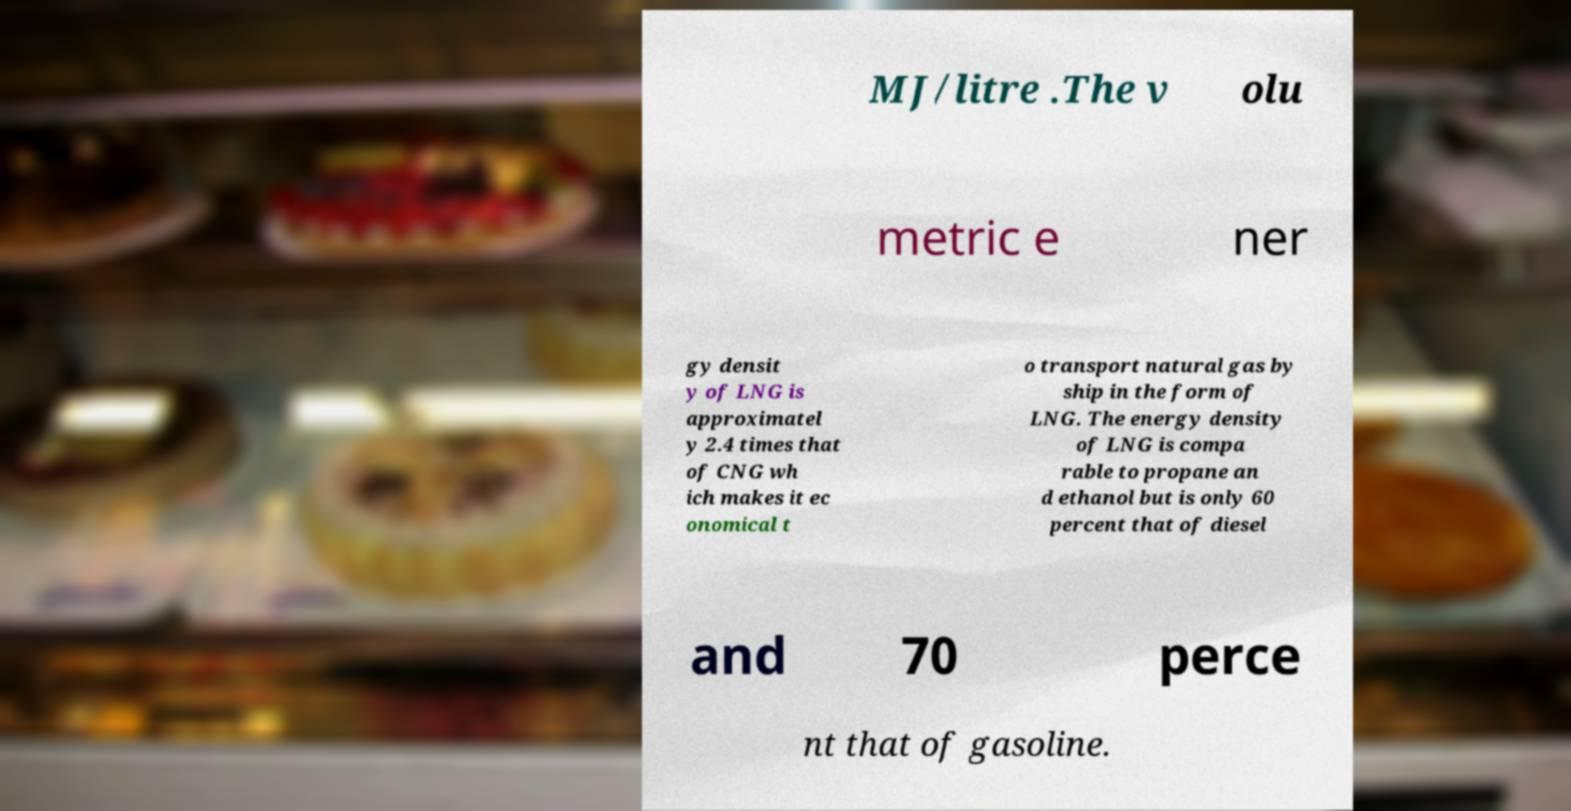I need the written content from this picture converted into text. Can you do that? MJ/litre .The v olu metric e ner gy densit y of LNG is approximatel y 2.4 times that of CNG wh ich makes it ec onomical t o transport natural gas by ship in the form of LNG. The energy density of LNG is compa rable to propane an d ethanol but is only 60 percent that of diesel and 70 perce nt that of gasoline. 